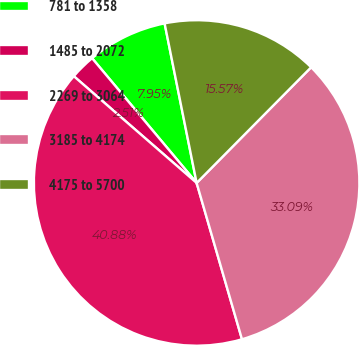Convert chart. <chart><loc_0><loc_0><loc_500><loc_500><pie_chart><fcel>781 to 1358<fcel>1485 to 2072<fcel>2269 to 3064<fcel>3185 to 4174<fcel>4175 to 5700<nl><fcel>7.95%<fcel>2.51%<fcel>40.88%<fcel>33.09%<fcel>15.57%<nl></chart> 